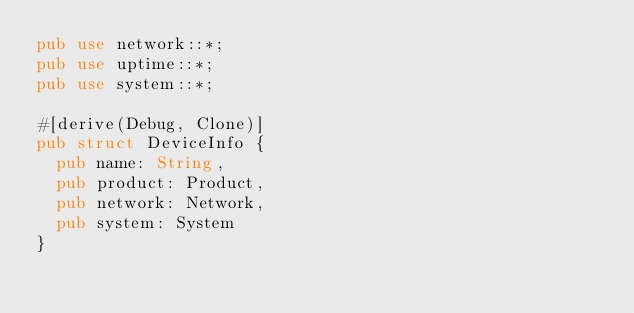Convert code to text. <code><loc_0><loc_0><loc_500><loc_500><_Rust_>pub use network::*;
pub use uptime::*;
pub use system::*;

#[derive(Debug, Clone)]
pub struct DeviceInfo {
  pub name: String,
  pub product: Product,
  pub network: Network,
  pub system: System
}</code> 